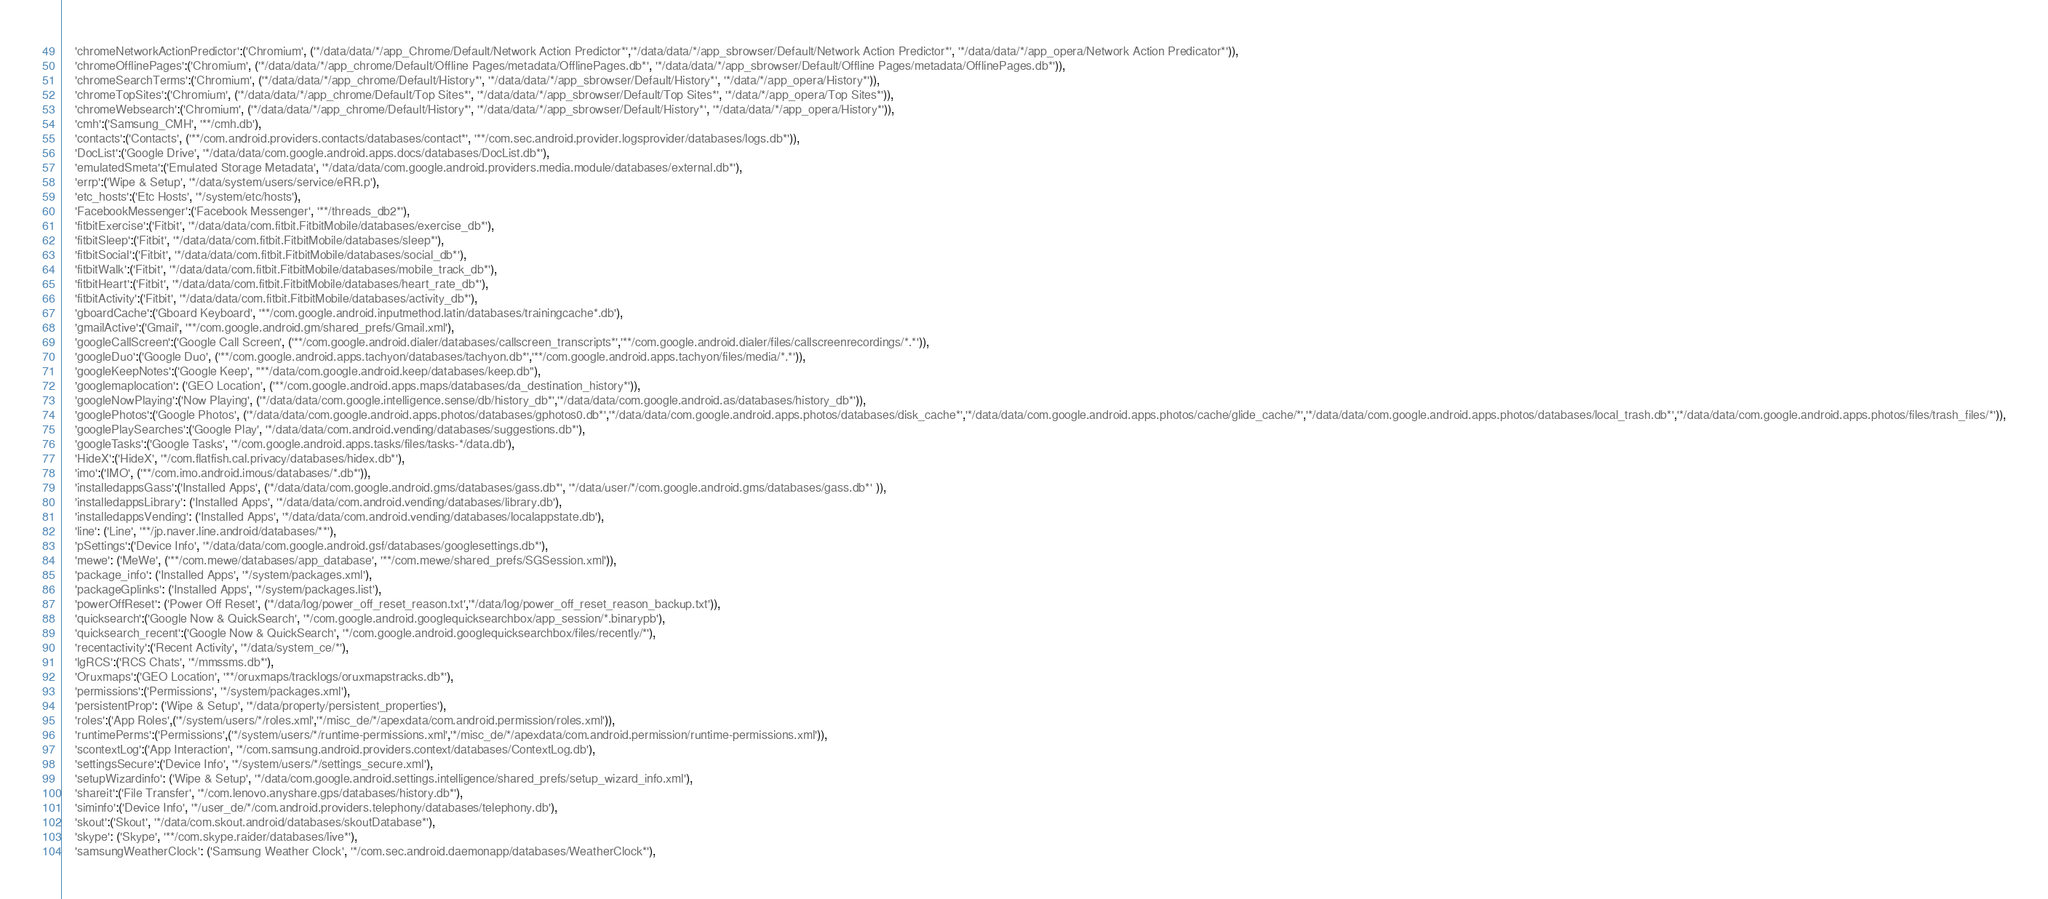<code> <loc_0><loc_0><loc_500><loc_500><_Python_>    'chromeNetworkActionPredictor':('Chromium', ('*/data/data/*/app_Chrome/Default/Network Action Predictor*','*/data/data/*/app_sbrowser/Default/Network Action Predictor*', '*/data/data/*/app_opera/Network Action Predicator*')),
    'chromeOfflinePages':('Chromium', ('*/data/data/*/app_chrome/Default/Offline Pages/metadata/OfflinePages.db*', '*/data/data/*/app_sbrowser/Default/Offline Pages/metadata/OfflinePages.db*')),
    'chromeSearchTerms':('Chromium', ('*/data/data/*/app_chrome/Default/History*', '*/data/data/*/app_sbrowser/Default/History*', '*/data/*/app_opera/History*')),
    'chromeTopSites':('Chromium', ('*/data/data/*/app_chrome/Default/Top Sites*', '*/data/data/*/app_sbrowser/Default/Top Sites*', '*/data/*/app_opera/Top Sites*')),
    'chromeWebsearch':('Chromium', ('*/data/data/*/app_chrome/Default/History*', '*/data/data/*/app_sbrowser/Default/History*', '*/data/data/*/app_opera/History*')),
    'cmh':('Samsung_CMH', '**/cmh.db'),
    'contacts':('Contacts', ('**/com.android.providers.contacts/databases/contact*', '**/com.sec.android.provider.logsprovider/databases/logs.db*')),
    'DocList':('Google Drive', '*/data/data/com.google.android.apps.docs/databases/DocList.db*'),
    'emulatedSmeta':('Emulated Storage Metadata', '*/data/data/com.google.android.providers.media.module/databases/external.db*'),
    'errp':('Wipe & Setup', '*/data/system/users/service/eRR.p'),
    'etc_hosts':('Etc Hosts', '*/system/etc/hosts'),
    'FacebookMessenger':('Facebook Messenger', '**/threads_db2*'),
    'fitbitExercise':('Fitbit', '*/data/data/com.fitbit.FitbitMobile/databases/exercise_db*'),
    'fitbitSleep':('Fitbit', '*/data/data/com.fitbit.FitbitMobile/databases/sleep*'),
    'fitbitSocial':('Fitbit', '*/data/data/com.fitbit.FitbitMobile/databases/social_db*'),
    'fitbitWalk':('Fitbit', '*/data/data/com.fitbit.FitbitMobile/databases/mobile_track_db*'),
    'fitbitHeart':('Fitbit', '*/data/data/com.fitbit.FitbitMobile/databases/heart_rate_db*'),
    'fitbitActivity':('Fitbit', '*/data/data/com.fitbit.FitbitMobile/databases/activity_db*'),
    'gboardCache':('Gboard Keyboard', '**/com.google.android.inputmethod.latin/databases/trainingcache*.db'),
    'gmailActive':('Gmail', '**/com.google.android.gm/shared_prefs/Gmail.xml'),
    'googleCallScreen':('Google Call Screen', ('**/com.google.android.dialer/databases/callscreen_transcripts*','**/com.google.android.dialer/files/callscreenrecordings/*.*')),
    'googleDuo':('Google Duo', ('**/com.google.android.apps.tachyon/databases/tachyon.db*','**/com.google.android.apps.tachyon/files/media/*.*')),
    'googleKeepNotes':('Google Keep', "**/data/com.google.android.keep/databases/keep.db"),
    'googlemaplocation': ('GEO Location', ('**/com.google.android.apps.maps/databases/da_destination_history*')),
    'googleNowPlaying':('Now Playing', ('*/data/data/com.google.intelligence.sense/db/history_db*','*/data/data/com.google.android.as/databases/history_db*')),
    'googlePhotos':('Google Photos', ('*/data/data/com.google.android.apps.photos/databases/gphotos0.db*','*/data/data/com.google.android.apps.photos/databases/disk_cache*','*/data/data/com.google.android.apps.photos/cache/glide_cache/*','*/data/data/com.google.android.apps.photos/databases/local_trash.db*','*/data/data/com.google.android.apps.photos/files/trash_files/*')),
    'googlePlaySearches':('Google Play', '*/data/data/com.android.vending/databases/suggestions.db*'),
    'googleTasks':('Google Tasks', '*/com.google.android.apps.tasks/files/tasks-*/data.db'),
    'HideX':('HideX', '*/com.flatfish.cal.privacy/databases/hidex.db*'),
    'imo':('IMO', ('**/com.imo.android.imous/databases/*.db*')),
    'installedappsGass':('Installed Apps', ('*/data/data/com.google.android.gms/databases/gass.db*', '*/data/user/*/com.google.android.gms/databases/gass.db*' )),
    'installedappsLibrary': ('Installed Apps', '*/data/data/com.android.vending/databases/library.db'),
    'installedappsVending': ('Installed Apps', '*/data/data/com.android.vending/databases/localappstate.db'),
    'line': ('Line', '**/jp.naver.line.android/databases/**'),
    'pSettings':('Device Info', '*/data/data/com.google.android.gsf/databases/googlesettings.db*'),
    'mewe': ('MeWe', ('**/com.mewe/databases/app_database', '**/com.mewe/shared_prefs/SGSession.xml')),
    'package_info': ('Installed Apps', '*/system/packages.xml'),
    'packageGplinks': ('Installed Apps', '*/system/packages.list'),
    'powerOffReset': ('Power Off Reset', ('*/data/log/power_off_reset_reason.txt','*/data/log/power_off_reset_reason_backup.txt')),
    'quicksearch':('Google Now & QuickSearch', '*/com.google.android.googlequicksearchbox/app_session/*.binarypb'),
    'quicksearch_recent':('Google Now & QuickSearch', '*/com.google.android.googlequicksearchbox/files/recently/*'),
    'recentactivity':('Recent Activity', '*/data/system_ce/*'),
    'lgRCS':('RCS Chats', '*/mmssms.db*'),
    'Oruxmaps':('GEO Location', '**/oruxmaps/tracklogs/oruxmapstracks.db*'),
    'permissions':('Permissions', '*/system/packages.xml'),
    'persistentProp': ('Wipe & Setup', '*/data/property/persistent_properties'),
    'roles':('App Roles',('*/system/users/*/roles.xml','*/misc_de/*/apexdata/com.android.permission/roles.xml')),
    'runtimePerms':('Permissions',('*/system/users/*/runtime-permissions.xml','*/misc_de/*/apexdata/com.android.permission/runtime-permissions.xml')),
    'scontextLog':('App Interaction', '*/com.samsung.android.providers.context/databases/ContextLog.db'),
    'settingsSecure':('Device Info', '*/system/users/*/settings_secure.xml'),
    'setupWizardinfo': ('Wipe & Setup', '*/data/com.google.android.settings.intelligence/shared_prefs/setup_wizard_info.xml'),
    'shareit':('File Transfer', '*/com.lenovo.anyshare.gps/databases/history.db*'),
    'siminfo':('Device Info', '*/user_de/*/com.android.providers.telephony/databases/telephony.db'),
    'skout':('Skout', '*/data/com.skout.android/databases/skoutDatabase*'),
    'skype': ('Skype', '**/com.skype.raider/databases/live*'),
    'samsungWeatherClock': ('Samsung Weather Clock', '*/com.sec.android.daemonapp/databases/WeatherClock*'),</code> 